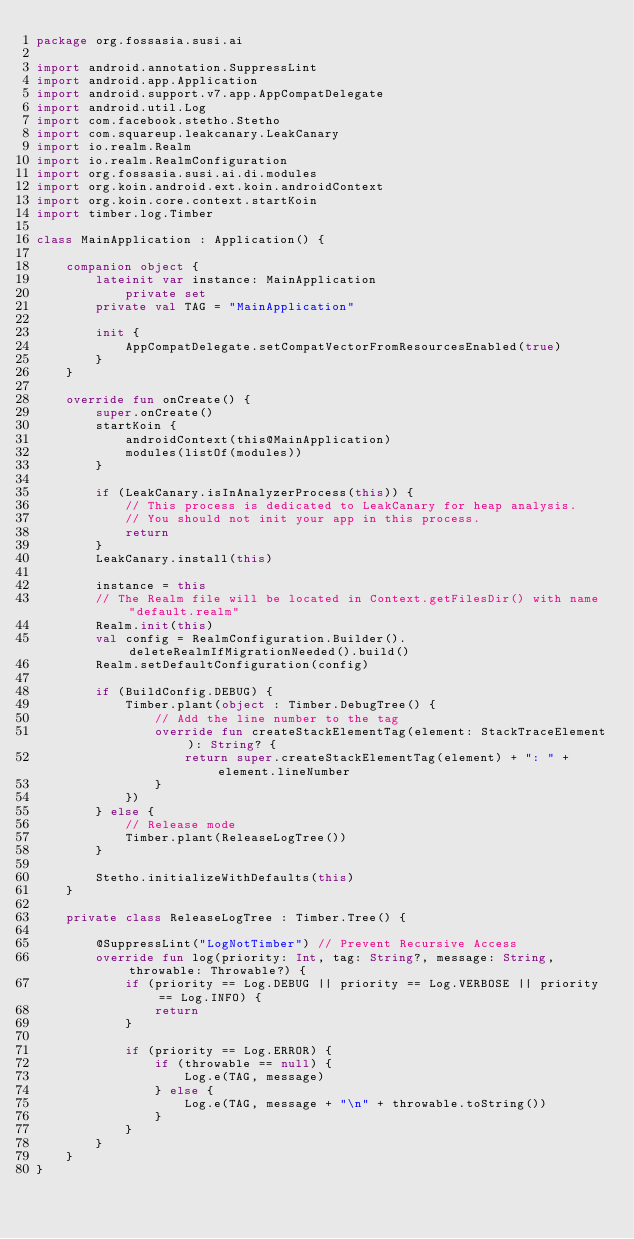<code> <loc_0><loc_0><loc_500><loc_500><_Kotlin_>package org.fossasia.susi.ai

import android.annotation.SuppressLint
import android.app.Application
import android.support.v7.app.AppCompatDelegate
import android.util.Log
import com.facebook.stetho.Stetho
import com.squareup.leakcanary.LeakCanary
import io.realm.Realm
import io.realm.RealmConfiguration
import org.fossasia.susi.ai.di.modules
import org.koin.android.ext.koin.androidContext
import org.koin.core.context.startKoin
import timber.log.Timber

class MainApplication : Application() {

    companion object {
        lateinit var instance: MainApplication
            private set
        private val TAG = "MainApplication"

        init {
            AppCompatDelegate.setCompatVectorFromResourcesEnabled(true)
        }
    }

    override fun onCreate() {
        super.onCreate()
        startKoin {
            androidContext(this@MainApplication)
            modules(listOf(modules))
        }

        if (LeakCanary.isInAnalyzerProcess(this)) {
            // This process is dedicated to LeakCanary for heap analysis.
            // You should not init your app in this process.
            return
        }
        LeakCanary.install(this)

        instance = this
        // The Realm file will be located in Context.getFilesDir() with name "default.realm"
        Realm.init(this)
        val config = RealmConfiguration.Builder().deleteRealmIfMigrationNeeded().build()
        Realm.setDefaultConfiguration(config)

        if (BuildConfig.DEBUG) {
            Timber.plant(object : Timber.DebugTree() {
                // Add the line number to the tag
                override fun createStackElementTag(element: StackTraceElement): String? {
                    return super.createStackElementTag(element) + ": " + element.lineNumber
                }
            })
        } else {
            // Release mode
            Timber.plant(ReleaseLogTree())
        }

        Stetho.initializeWithDefaults(this)
    }

    private class ReleaseLogTree : Timber.Tree() {

        @SuppressLint("LogNotTimber") // Prevent Recursive Access
        override fun log(priority: Int, tag: String?, message: String, throwable: Throwable?) {
            if (priority == Log.DEBUG || priority == Log.VERBOSE || priority == Log.INFO) {
                return
            }

            if (priority == Log.ERROR) {
                if (throwable == null) {
                    Log.e(TAG, message)
                } else {
                    Log.e(TAG, message + "\n" + throwable.toString())
                }
            }
        }
    }
}
</code> 